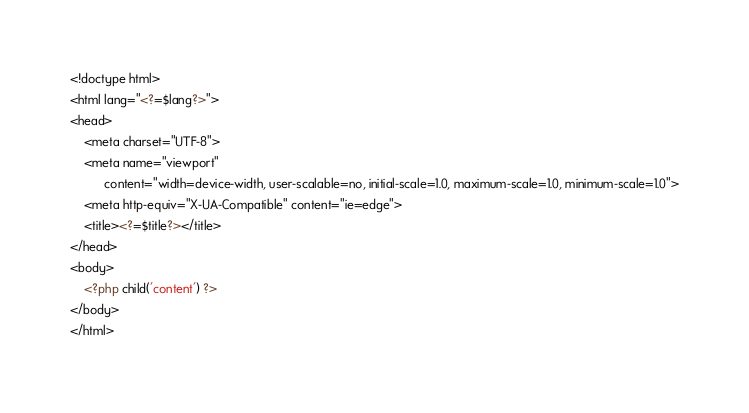Convert code to text. <code><loc_0><loc_0><loc_500><loc_500><_PHP_><!doctype html>
<html lang="<?=$lang?>">
<head>
    <meta charset="UTF-8">
    <meta name="viewport"
          content="width=device-width, user-scalable=no, initial-scale=1.0, maximum-scale=1.0, minimum-scale=1.0">
    <meta http-equiv="X-UA-Compatible" content="ie=edge">
    <title><?=$title?></title>
</head>
<body>
    <?php child('content') ?>
</body>
</html></code> 